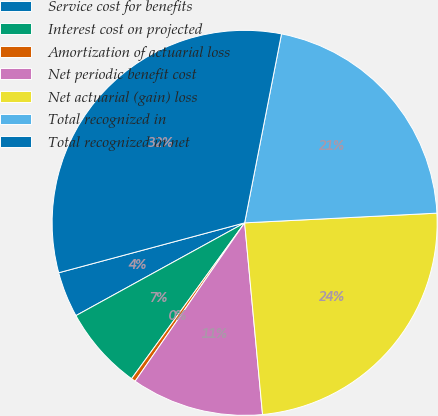Convert chart. <chart><loc_0><loc_0><loc_500><loc_500><pie_chart><fcel>Service cost for benefits<fcel>Interest cost on projected<fcel>Amortization of actuarial loss<fcel>Net periodic benefit cost<fcel>Net actuarial (gain) loss<fcel>Total recognized in<fcel>Total recognized in net<nl><fcel>3.83%<fcel>7.01%<fcel>0.36%<fcel>11.11%<fcel>24.32%<fcel>21.13%<fcel>32.24%<nl></chart> 